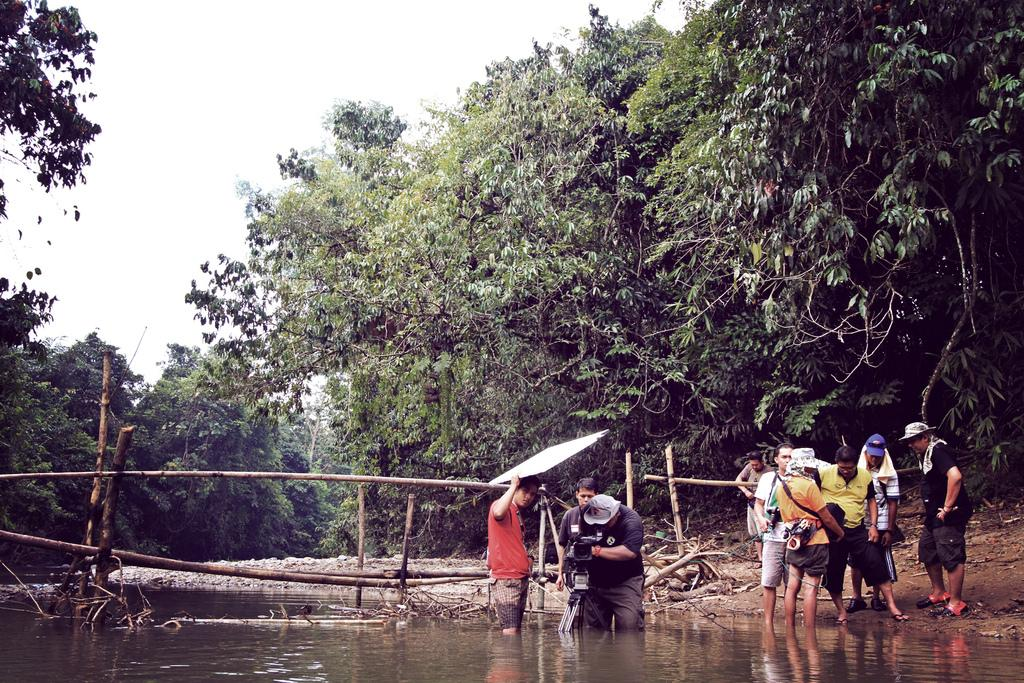How many people are in the image? There are people in the image, but the exact number is not specified. What are some people doing in the image? Some people are holding objects, and some are in the water. What can be seen on the ground in the image? The ground is visible in the image. What structures are present in the image? There are wooden poles in the image. What type of vegetation is visible in the image? There are trees in the image. What part of the natural environment is visible in the image? The sky is visible in the image. What type of goat can be seen interacting with the wooden poles in the image? There is no goat present in the image; it features people, objects, water, ground, wooden poles, trees, and the sky. 